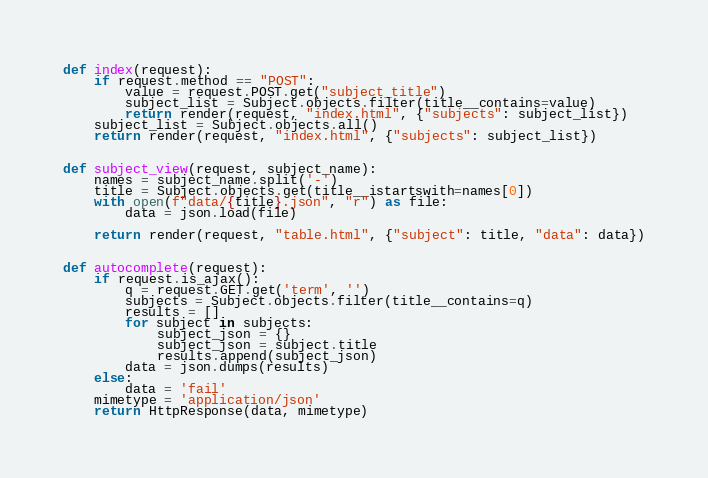Convert code to text. <code><loc_0><loc_0><loc_500><loc_500><_Python_>
def index(request):
    if request.method == "POST":
        value = request.POST.get("subject_title")
        subject_list = Subject.objects.filter(title__contains=value)
        return render(request, "index.html", {"subjects": subject_list})
    subject_list = Subject.objects.all()
    return render(request, "index.html", {"subjects": subject_list})


def subject_view(request, subject_name):
    names = subject_name.split('-')
    title = Subject.objects.get(title__istartswith=names[0])
    with open(f"data/{title}.json", "r") as file:
        data = json.load(file)

    return render(request, "table.html", {"subject": title, "data": data})


def autocomplete(request):
    if request.is_ajax():
        q = request.GET.get('term', '')
        subjects = Subject.objects.filter(title__contains=q)
        results = []
        for subject in subjects:
            subject_json = {}
            subject_json = subject.title
            results.append(subject_json)
        data = json.dumps(results)
    else:
        data = 'fail'
    mimetype = 'application/json'
    return HttpResponse(data, mimetype)
</code> 